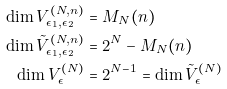<formula> <loc_0><loc_0><loc_500><loc_500>\dim V ^ { ( N , n ) } _ { \epsilon _ { 1 } , \epsilon _ { 2 } } & = M _ { N } ( n ) \\ \dim \tilde { V } ^ { ( N , n ) } _ { \epsilon _ { 1 } , \epsilon _ { 2 } } & = 2 ^ { N } - M _ { N } ( n ) \\ \dim V ^ { ( N ) } _ { \epsilon } & = 2 ^ { N - 1 } = \dim \tilde { V } ^ { ( N ) } _ { \epsilon }</formula> 